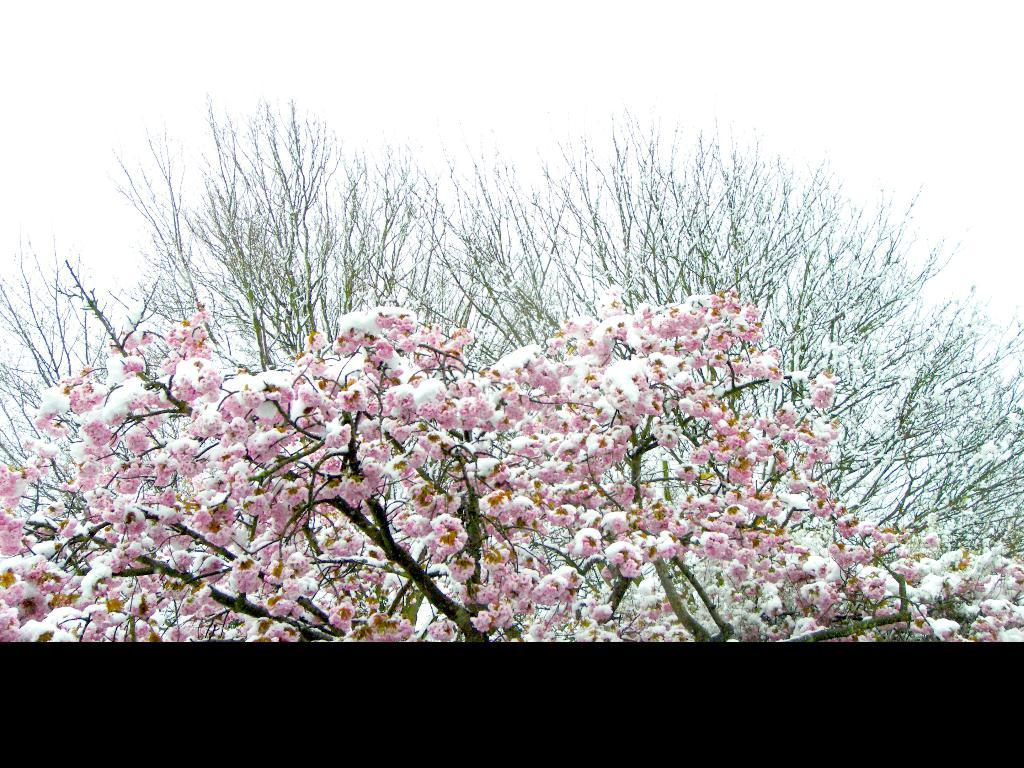What type of plant is visible on the tree in the image? There are flowers on the tree in the image. What color are the flowers on the tree? The flowers on the tree are pink in color. What type of badge can be seen hanging from the tree in the image? There is no badge present in the image; it features flowers on a tree. What type of ink is used to color the flowers in the image? The image is not a drawing or painting, so there is no ink used to color the flowers. 